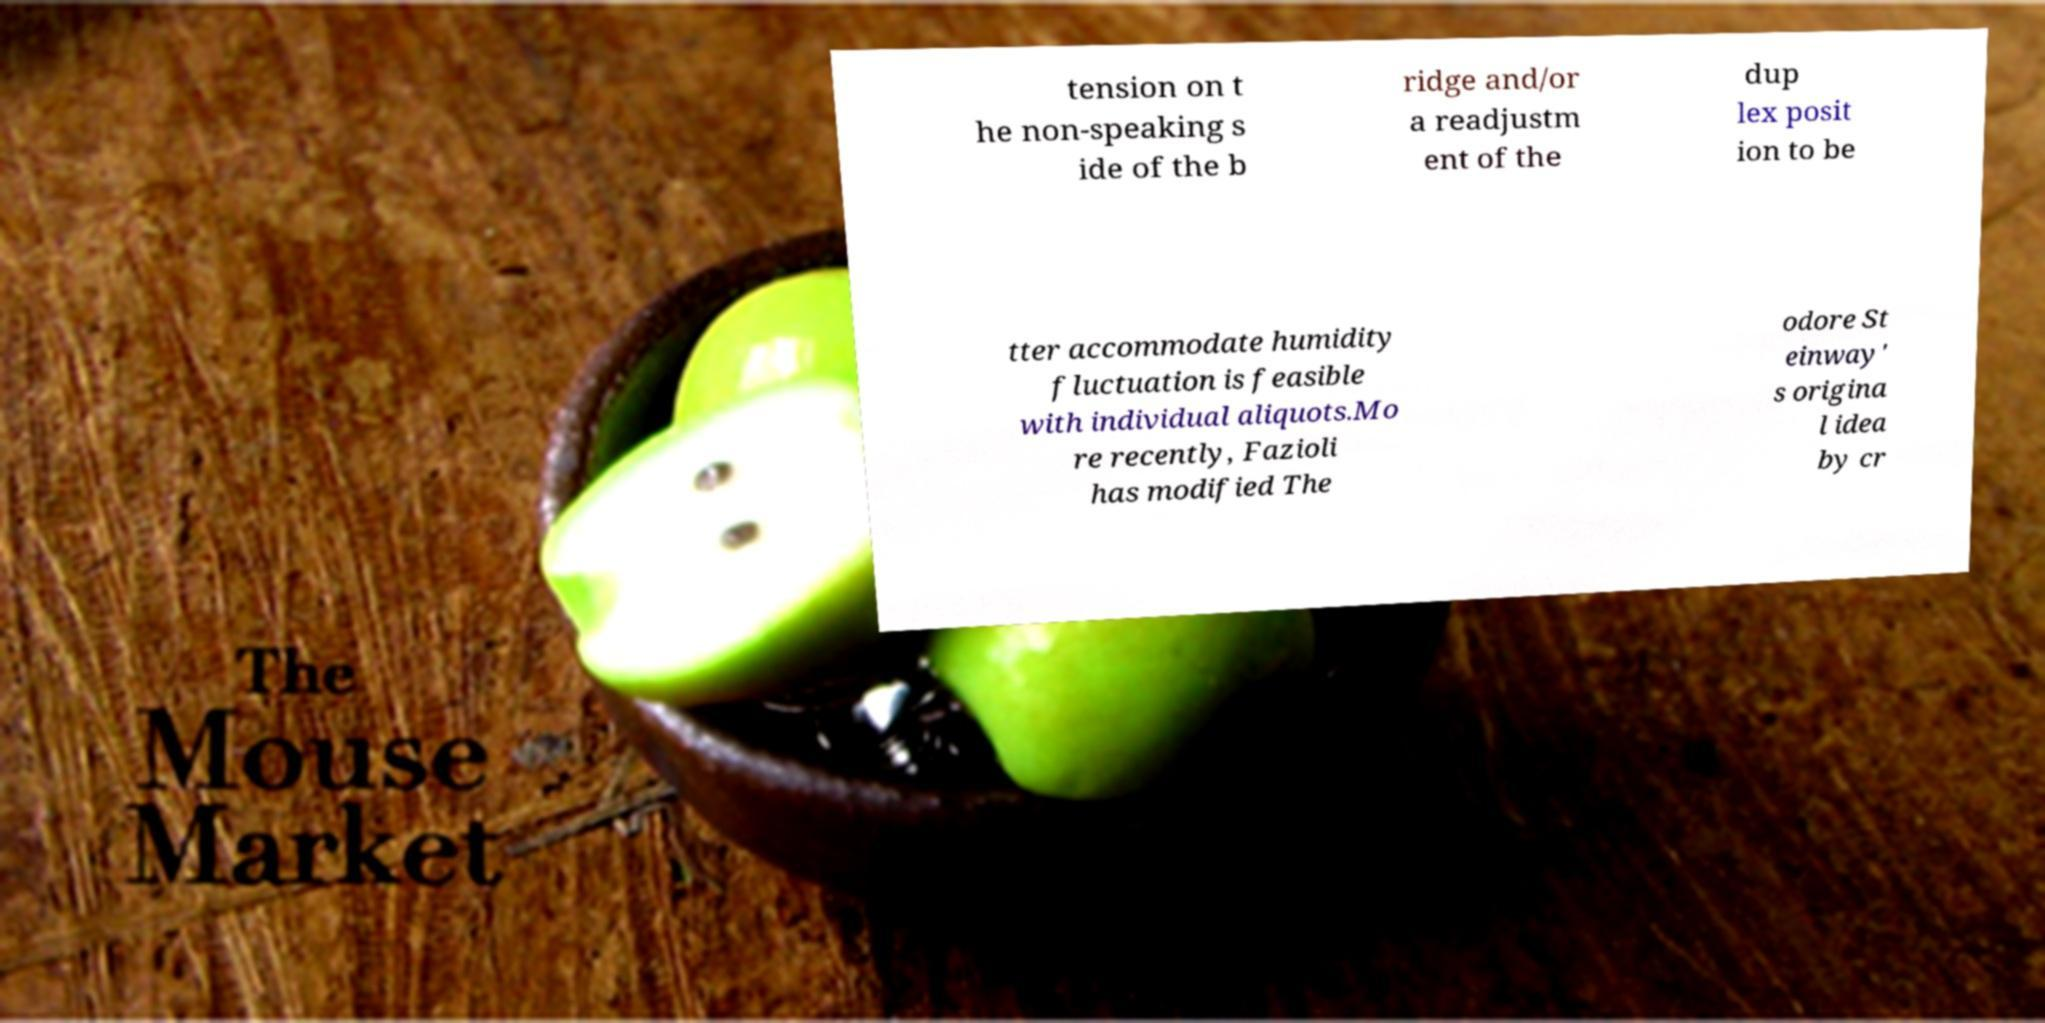Can you read and provide the text displayed in the image?This photo seems to have some interesting text. Can you extract and type it out for me? tension on t he non-speaking s ide of the b ridge and/or a readjustm ent of the dup lex posit ion to be tter accommodate humidity fluctuation is feasible with individual aliquots.Mo re recently, Fazioli has modified The odore St einway' s origina l idea by cr 